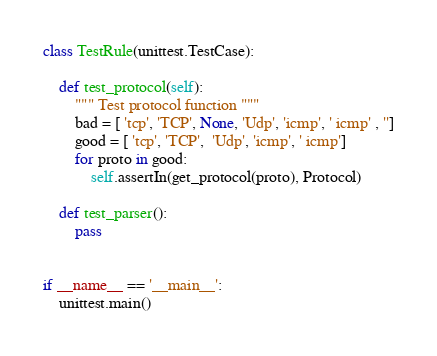<code> <loc_0><loc_0><loc_500><loc_500><_Python_>class TestRule(unittest.TestCase):

    def test_protocol(self):
        """ Test protocol function """
        bad = [ 'tcp', 'TCP', None, 'Udp', 'icmp', ' icmp' , '']
        good = [ 'tcp', 'TCP',  'Udp', 'icmp', ' icmp']
        for proto in good:
            self.assertIn(get_protocol(proto), Protocol)
    
    def test_parser():
        pass
        

if __name__ == '__main__':
    unittest.main()</code> 